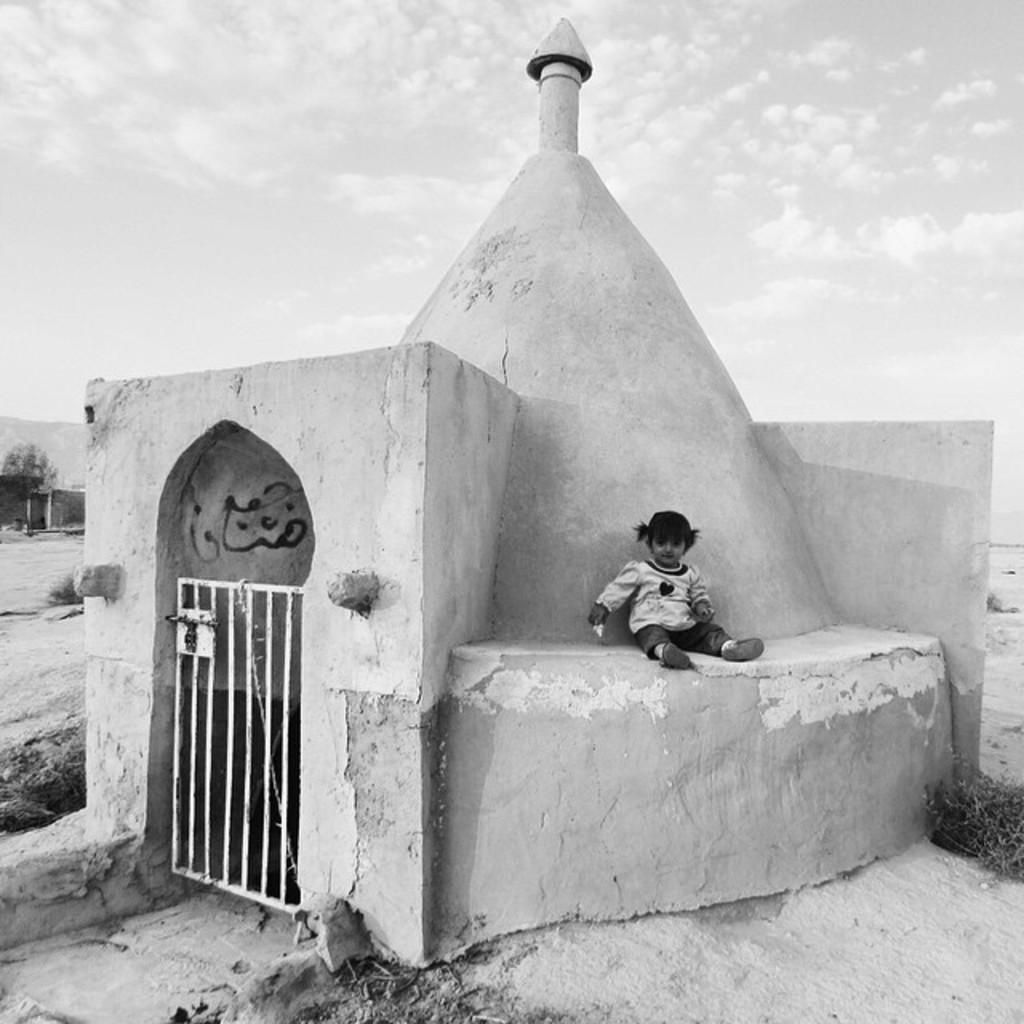What is the main subject of the image? The main subject of the image is a little girl sitting. What can be seen on the left side of the image? There is an iron gate on the left side of the image. What type of desk is visible in the image? There is no desk present in the image. Can you tell me how the drum is being played in the image? There is no drum present in the image. 